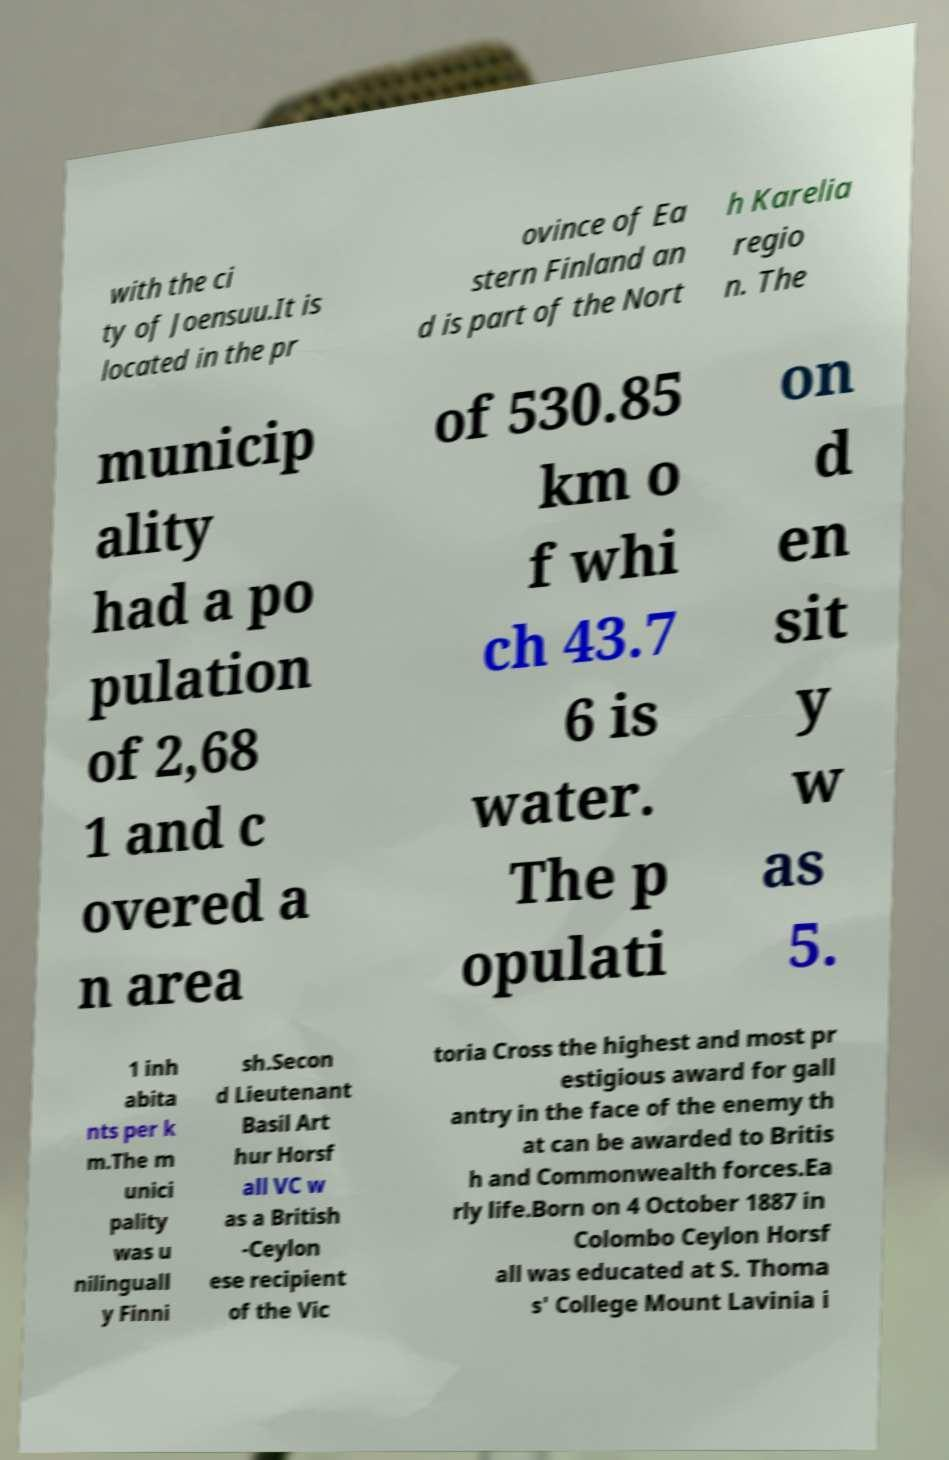Could you extract and type out the text from this image? with the ci ty of Joensuu.It is located in the pr ovince of Ea stern Finland an d is part of the Nort h Karelia regio n. The municip ality had a po pulation of 2,68 1 and c overed a n area of 530.85 km o f whi ch 43.7 6 is water. The p opulati on d en sit y w as 5. 1 inh abita nts per k m.The m unici pality was u nilinguall y Finni sh.Secon d Lieutenant Basil Art hur Horsf all VC w as a British -Ceylon ese recipient of the Vic toria Cross the highest and most pr estigious award for gall antry in the face of the enemy th at can be awarded to Britis h and Commonwealth forces.Ea rly life.Born on 4 October 1887 in Colombo Ceylon Horsf all was educated at S. Thoma s' College Mount Lavinia i 